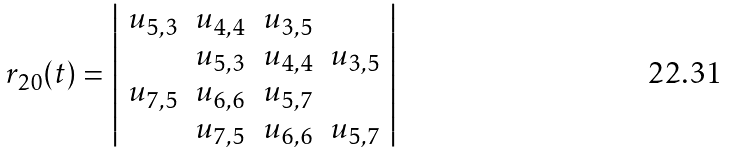Convert formula to latex. <formula><loc_0><loc_0><loc_500><loc_500>r _ { 2 0 } ( t ) = \left | \begin{array} { c c c c } u _ { 5 , 3 } & u _ { 4 , 4 } & u _ { 3 , 5 } & \\ & u _ { 5 , 3 } & u _ { 4 , 4 } & u _ { 3 , 5 } \\ u _ { 7 , 5 } & u _ { 6 , 6 } & u _ { 5 , 7 } & \\ & u _ { 7 , 5 } & u _ { 6 , 6 } & u _ { 5 , 7 } \end{array} \right |</formula> 